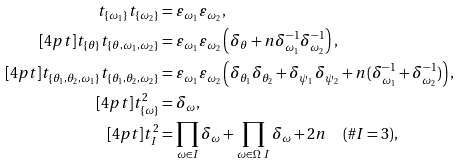<formula> <loc_0><loc_0><loc_500><loc_500>t _ { \{ \omega _ { 1 } \} } t _ { \{ \omega _ { 2 } \} } & = \varepsilon _ { \omega _ { 1 } } \varepsilon _ { \omega _ { 2 } } , \\ [ 4 p t ] t _ { \{ \theta \} } t _ { \{ \theta , \omega _ { 1 } , \omega _ { 2 } \} } & = \varepsilon _ { \omega _ { 1 } } \varepsilon _ { \omega _ { 2 } } \left ( \delta _ { \theta } + n \delta _ { \omega _ { 1 } } ^ { - 1 } \delta _ { \omega _ { 2 } } ^ { - 1 } \right ) , \\ [ 4 p t ] t _ { \{ \theta _ { 1 } , \theta _ { 2 } , \omega _ { 1 } \} } t _ { \{ \theta _ { 1 } , \theta _ { 2 } , \omega _ { 2 } \} } & = \varepsilon _ { \omega _ { 1 } } \varepsilon _ { \omega _ { 2 } } \left ( \delta _ { \theta _ { 1 } } \delta _ { \theta _ { 2 } } + \delta _ { \psi _ { 1 } } \delta _ { \psi _ { 2 } } + n ( \delta _ { \omega _ { 1 } } ^ { - 1 } + \delta _ { \omega _ { 2 } } ^ { - 1 } ) \right ) , \\ [ 4 p t ] t _ { \{ \omega \} } ^ { 2 } & = \delta _ { \omega } , \\ [ 4 p t ] t _ { I } ^ { 2 } & = \prod _ { \omega \in I } \delta _ { \omega } + \prod _ { \omega \in \Omega \ I } \delta _ { \omega } + 2 n \quad ( \# I = 3 ) ,</formula> 